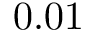Convert formula to latex. <formula><loc_0><loc_0><loc_500><loc_500>0 . 0 1</formula> 